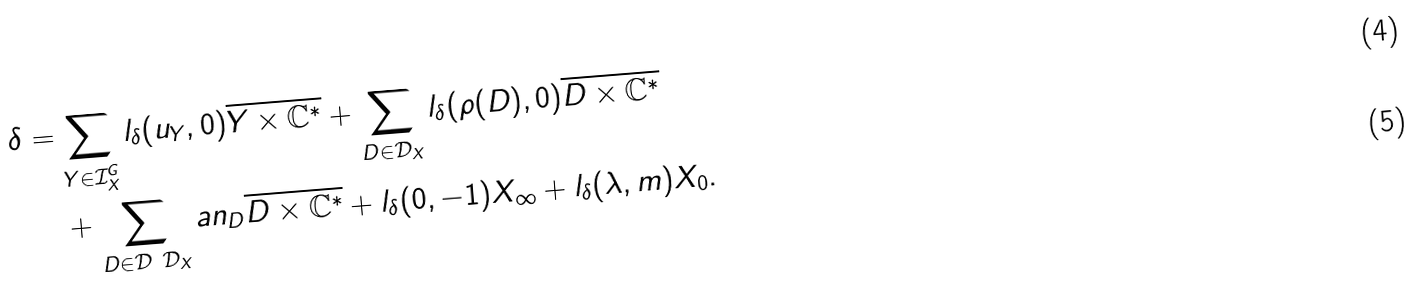<formula> <loc_0><loc_0><loc_500><loc_500>\delta = & \sum _ { Y \in \mathcal { I } _ { X } ^ { G } } l _ { \delta } ( u _ { Y } , 0 ) \overline { Y \times \mathbb { C } ^ { * } } + \sum _ { D \in \mathcal { D } _ { X } } l _ { \delta } ( \rho ( D ) , 0 ) \overline { D \times \mathbb { C } ^ { * } } \\ & + \sum _ { D \in \mathcal { D } \ \mathcal { D } _ { X } } a n _ { D } \overline { D \times \mathbb { C } ^ { * } } + l _ { \delta } ( 0 , - 1 ) X _ { \infty } + l _ { \delta } ( \lambda , m ) X _ { 0 } .</formula> 